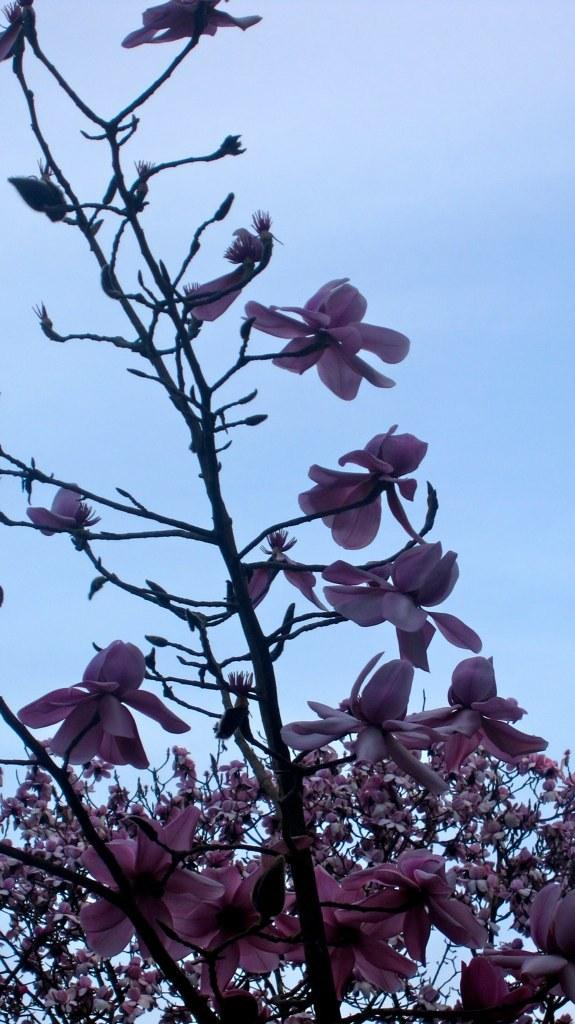What type of plant can be seen in the image? There is a tree in the image. What are the main features of the tree? The tree has branches, stems, and flowers. What can be seen in the background of the image? The sky is visible in the background of the image. What type of orange net can be seen surrounding the tree in the image? There is no orange net present in the image; the tree is not surrounded by any net. 